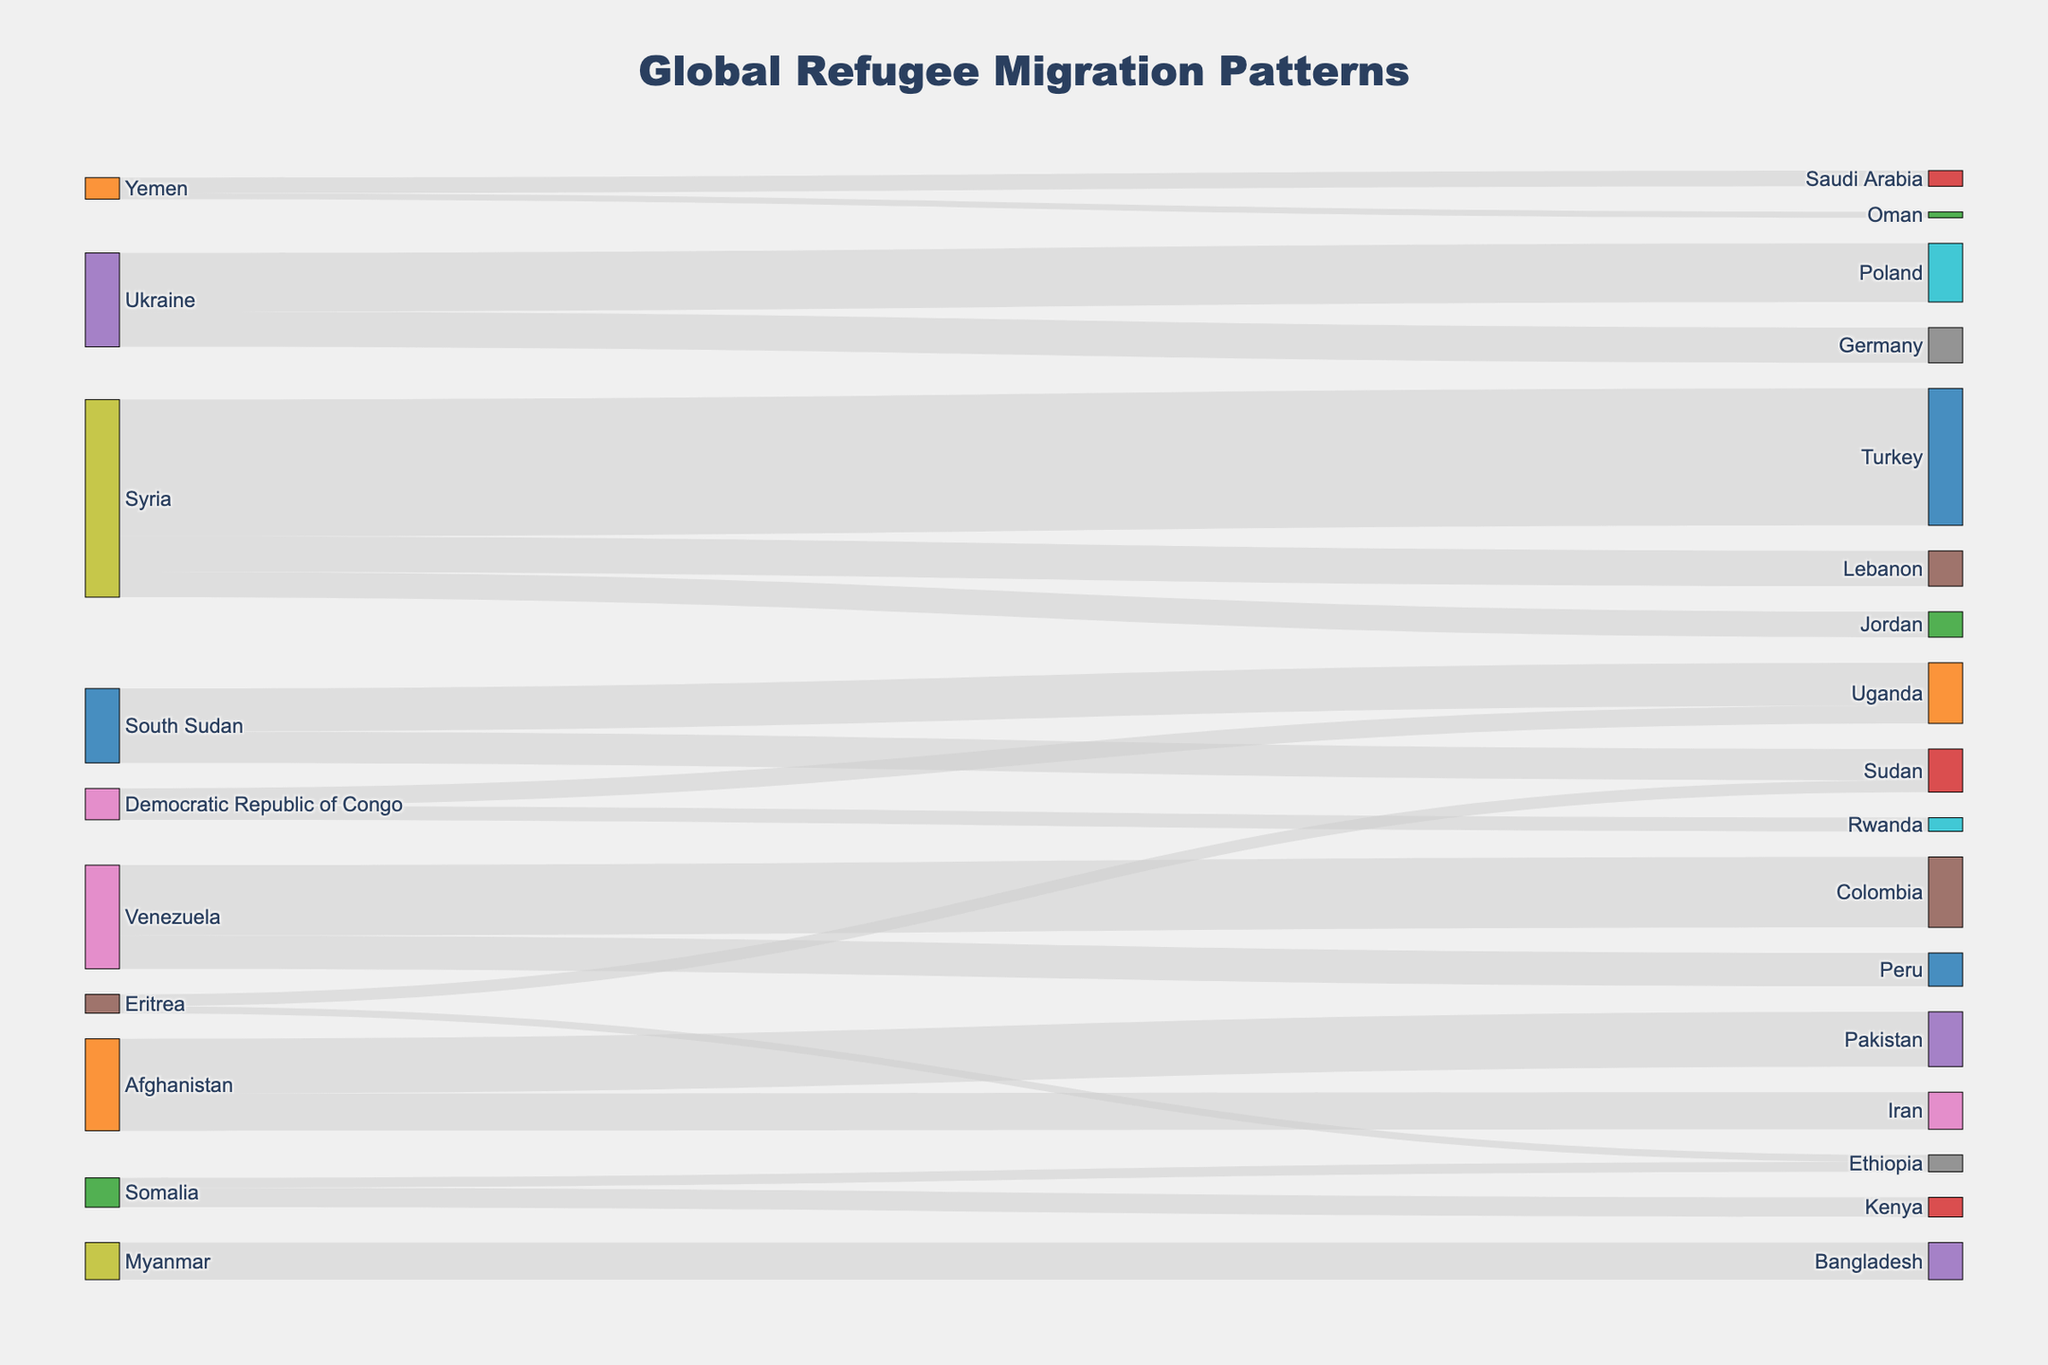What is the title of the figure? The title of the figure is prominently displayed at the top. It reads "Global Refugee Migration Patterns."
Answer: Global Refugee Migration Patterns Which country has the highest number of refugees in another country according to the figure? To identify the country with the highest number of refugees in another country, look at the width of the flows (bands) between nodes. The widest flow represents the largest number of refugees, which is from Syria to Turkey.
Answer: Syria to Turkey How many refugees are there from Afghanistan to Pakistan and Iran in total? To find the total number of refugees from Afghanistan to both Pakistan and Iran, add the values associated with these flows. Afghanistan to Pakistan has 1,400,000 refugees, and Afghanistan to Iran has 950,000 refugees. So, the total is 1,400,000 + 950,000 = 2,350,000.
Answer: 2,350,000 Which two countries are the main destination for refugees from Syria? To determine the main destination countries for refugees from Syria, observe the flows originating from Syria. The two primary destinations are Turkey (3,500,000 refugees) and Lebanon (900,000 refugees).
Answer: Turkey and Lebanon How does the number of refugees from Venezuela to Colombia compare with those from Venezuela to Peru? To compare the number of refugees from Venezuela to Colombia with those to Peru, look at the corresponding flows. Venezuela has 1,800,000 refugees to Colombia and 850,000 refugees to Peru. Thus, Venezuela to Colombia has more refugees.
Answer: More refugees to Colombia Which country hosts the largest number of Ukrainian refugees according to the source data? To find the country hosting the largest number of Ukrainian refugees, check the flows from Ukraine. Poland hosts 1,500,000 Ukrainian refugees, the largest number in this context.
Answer: Poland What is the combined number of refugees in Uganda from South Sudan and the Democratic Republic of Congo? To get the combined number of refugees in Uganda from South Sudan and the Democratic Republic of Congo, add the values of these flows. South Sudan to Uganda has 1,100,000 refugees, and Democratic Republic of Congo to Uganda has 450,000. Thus, 1,100,000 + 450,000 = 1,550,000.
Answer: 1,550,000 How many countries are sources of refugees in the diagram? To count the number of countries that serve as sources of refugees, look at the node list and identify unique countries in the 'source' column. There are nine such countries: Syria, Afghanistan, South Sudan, Myanmar, Venezuela, Democratic Republic of Congo, Somalia, Eritrea, and Yemen.
Answer: Nine What is the smallest refugee flow in the diagram? The smallest refugee flow can be identified by looking at the smallest-width band in the diagram. The flow from Yemen to Oman has the smallest value, which is 150,000 refugees.
Answer: Yemen to Oman 